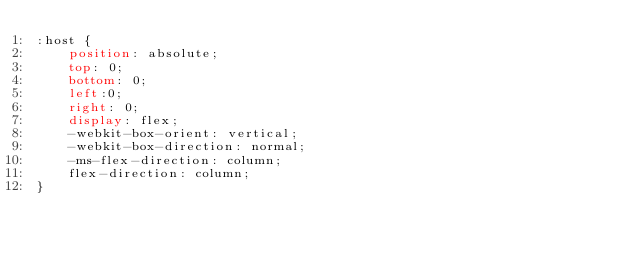Convert code to text. <code><loc_0><loc_0><loc_500><loc_500><_CSS_>:host {
    position: absolute;
    top: 0;
    bottom: 0;
    left:0;
    right: 0;
    display: flex;
    -webkit-box-orient: vertical;
    -webkit-box-direction: normal;
    -ms-flex-direction: column;
    flex-direction: column;
}
</code> 